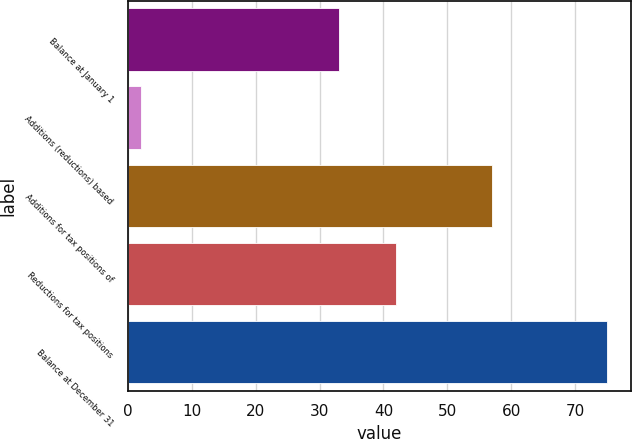Convert chart to OTSL. <chart><loc_0><loc_0><loc_500><loc_500><bar_chart><fcel>Balance at January 1<fcel>Additions (reductions) based<fcel>Additions for tax positions of<fcel>Reductions for tax positions<fcel>Balance at December 31<nl><fcel>33<fcel>2<fcel>57<fcel>42<fcel>75<nl></chart> 